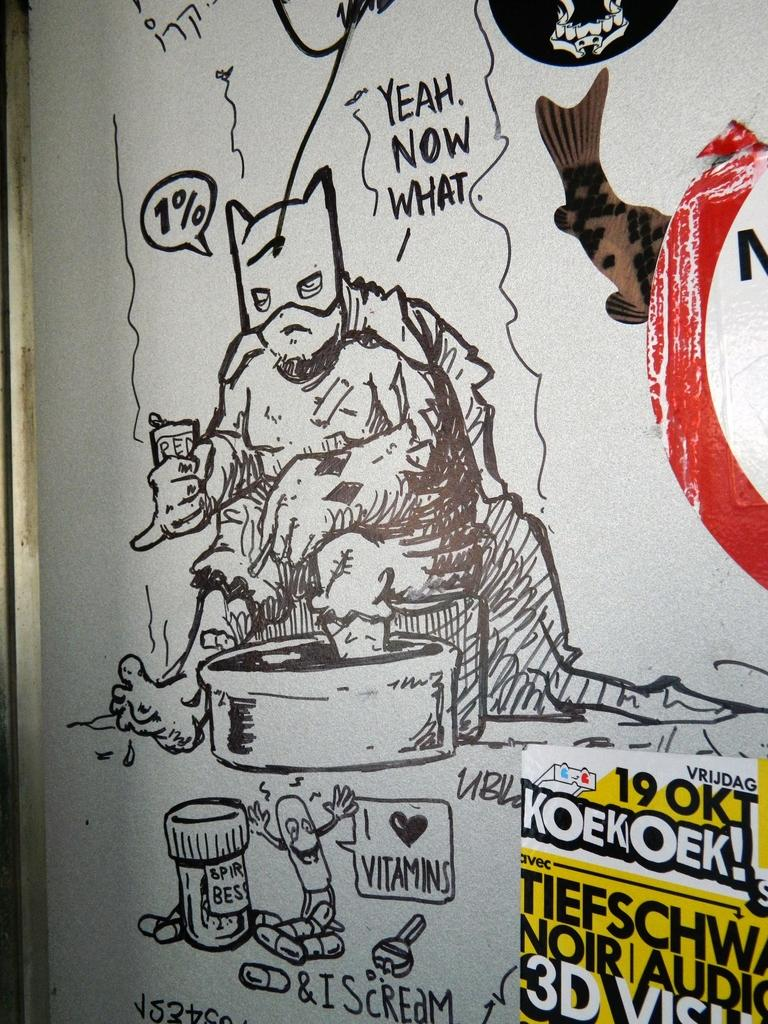What is present on the wall in the image? There is a painting on the wall in the image. Is there any additional information associated with the painting? Yes, there is text associated with the painting. What else can be seen on the right side of the image? There appears to be a poster on the right side of the image. What is the name of the person smiling in the painting? There is no person smiling in the painting, as it is an abstract piece of art. 